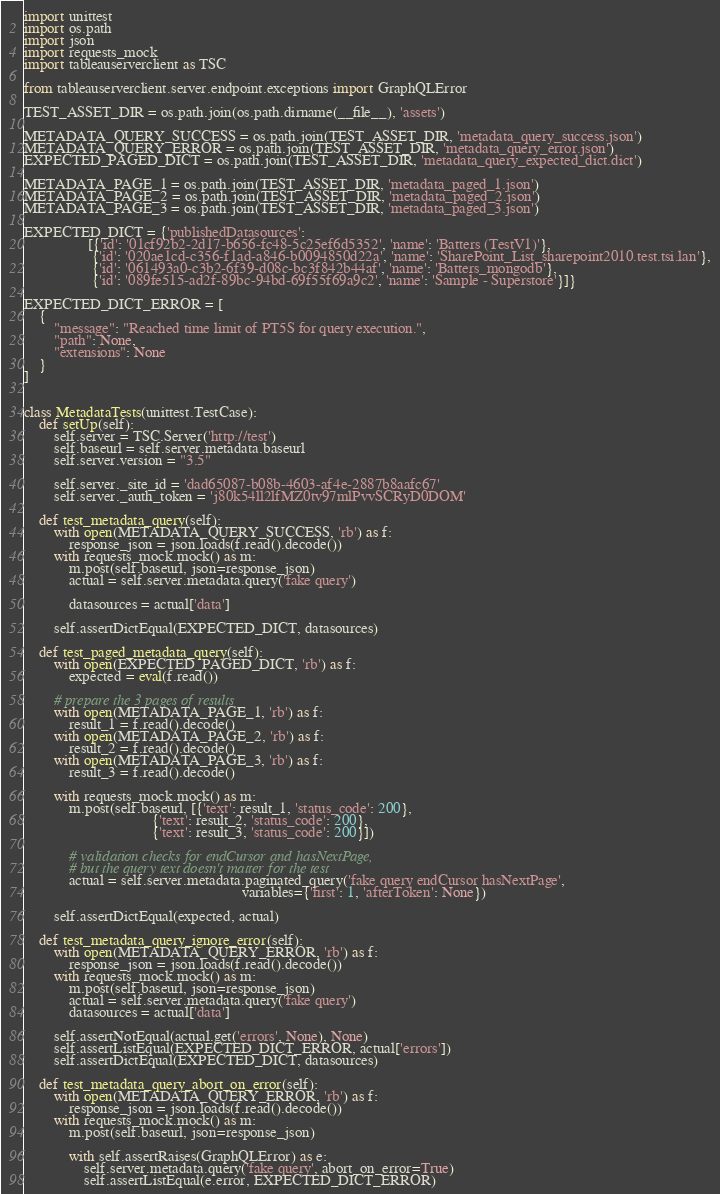Convert code to text. <code><loc_0><loc_0><loc_500><loc_500><_Python_>import unittest
import os.path
import json
import requests_mock
import tableauserverclient as TSC

from tableauserverclient.server.endpoint.exceptions import GraphQLError

TEST_ASSET_DIR = os.path.join(os.path.dirname(__file__), 'assets')

METADATA_QUERY_SUCCESS = os.path.join(TEST_ASSET_DIR, 'metadata_query_success.json')
METADATA_QUERY_ERROR = os.path.join(TEST_ASSET_DIR, 'metadata_query_error.json')
EXPECTED_PAGED_DICT = os.path.join(TEST_ASSET_DIR, 'metadata_query_expected_dict.dict')

METADATA_PAGE_1 = os.path.join(TEST_ASSET_DIR, 'metadata_paged_1.json')
METADATA_PAGE_2 = os.path.join(TEST_ASSET_DIR, 'metadata_paged_2.json')
METADATA_PAGE_3 = os.path.join(TEST_ASSET_DIR, 'metadata_paged_3.json')

EXPECTED_DICT = {'publishedDatasources':
                 [{'id': '01cf92b2-2d17-b656-fc48-5c25ef6d5352', 'name': 'Batters (TestV1)'},
                  {'id': '020ae1cd-c356-f1ad-a846-b0094850d22a', 'name': 'SharePoint_List_sharepoint2010.test.tsi.lan'},
                  {'id': '061493a0-c3b2-6f39-d08c-bc3f842b44af', 'name': 'Batters_mongodb'},
                  {'id': '089fe515-ad2f-89bc-94bd-69f55f69a9c2', 'name': 'Sample - Superstore'}]}

EXPECTED_DICT_ERROR = [
    {
        "message": "Reached time limit of PT5S for query execution.",
        "path": None,
        "extensions": None
    }
]


class MetadataTests(unittest.TestCase):
    def setUp(self):
        self.server = TSC.Server('http://test')
        self.baseurl = self.server.metadata.baseurl
        self.server.version = "3.5"

        self.server._site_id = 'dad65087-b08b-4603-af4e-2887b8aafc67'
        self.server._auth_token = 'j80k54ll2lfMZ0tv97mlPvvSCRyD0DOM'

    def test_metadata_query(self):
        with open(METADATA_QUERY_SUCCESS, 'rb') as f:
            response_json = json.loads(f.read().decode())
        with requests_mock.mock() as m:
            m.post(self.baseurl, json=response_json)
            actual = self.server.metadata.query('fake query')

            datasources = actual['data']

        self.assertDictEqual(EXPECTED_DICT, datasources)

    def test_paged_metadata_query(self):
        with open(EXPECTED_PAGED_DICT, 'rb') as f:
            expected = eval(f.read())

        # prepare the 3 pages of results
        with open(METADATA_PAGE_1, 'rb') as f:
            result_1 = f.read().decode()
        with open(METADATA_PAGE_2, 'rb') as f:
            result_2 = f.read().decode()
        with open(METADATA_PAGE_3, 'rb') as f:
            result_3 = f.read().decode()

        with requests_mock.mock() as m:
            m.post(self.baseurl, [{'text': result_1, 'status_code': 200},
                                  {'text': result_2, 'status_code': 200},
                                  {'text': result_3, 'status_code': 200}])

            # validation checks for endCursor and hasNextPage,
            # but the query text doesn't matter for the test
            actual = self.server.metadata.paginated_query('fake query endCursor hasNextPage',
                                                          variables={'first': 1, 'afterToken': None})

        self.assertDictEqual(expected, actual)

    def test_metadata_query_ignore_error(self):
        with open(METADATA_QUERY_ERROR, 'rb') as f:
            response_json = json.loads(f.read().decode())
        with requests_mock.mock() as m:
            m.post(self.baseurl, json=response_json)
            actual = self.server.metadata.query('fake query')
            datasources = actual['data']

        self.assertNotEqual(actual.get('errors', None), None)
        self.assertListEqual(EXPECTED_DICT_ERROR, actual['errors'])
        self.assertDictEqual(EXPECTED_DICT, datasources)

    def test_metadata_query_abort_on_error(self):
        with open(METADATA_QUERY_ERROR, 'rb') as f:
            response_json = json.loads(f.read().decode())
        with requests_mock.mock() as m:
            m.post(self.baseurl, json=response_json)

            with self.assertRaises(GraphQLError) as e:
                self.server.metadata.query('fake query', abort_on_error=True)
                self.assertListEqual(e.error, EXPECTED_DICT_ERROR)
</code> 